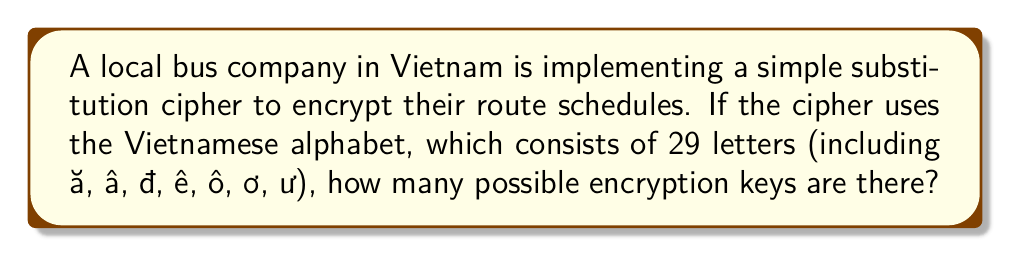Can you answer this question? To calculate the number of possible encryption keys in a simple substitution cipher, we need to determine the number of ways to arrange the letters of the alphabet. This is a permutation problem.

Step 1: Identify the number of letters in the alphabet.
The Vietnamese alphabet has 29 letters.

Step 2: Calculate the number of permutations.
The number of permutations of 29 distinct objects is given by the factorial of 29, denoted as 29!

$$29! = 29 \times 28 \times 27 \times ... \times 3 \times 2 \times 1$$

Step 3: Calculate the result.
Using a calculator or computer (due to the large number):

$$29! = 8.841761993739701 \times 10^{30}$$

This extremely large number represents the total number of possible encryption keys for a simple substitution cipher using the Vietnamese alphabet.
Answer: $29!$ or approximately $8.84 \times 10^{30}$ 